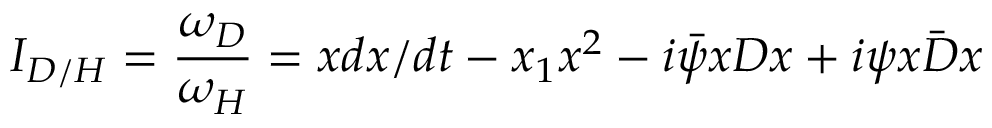<formula> <loc_0><loc_0><loc_500><loc_500>I _ { D / H } = \frac { \omega _ { D } } { \omega _ { H } } = x d x / d t - x _ { 1 } x ^ { 2 } - i \bar { \psi } x D x + i \psi x \bar { D } x</formula> 